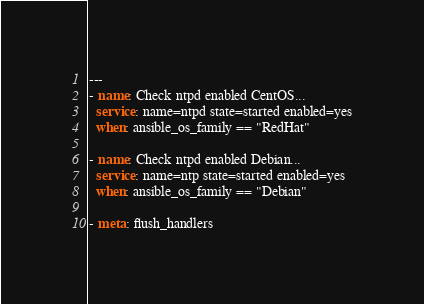<code> <loc_0><loc_0><loc_500><loc_500><_YAML_>---
- name: Check ntpd enabled CentOS...
  service: name=ntpd state=started enabled=yes
  when: ansible_os_family == "RedHat"

- name: Check ntpd enabled Debian...
  service: name=ntp state=started enabled=yes
  when: ansible_os_family == "Debian"

- meta: flush_handlers</code> 